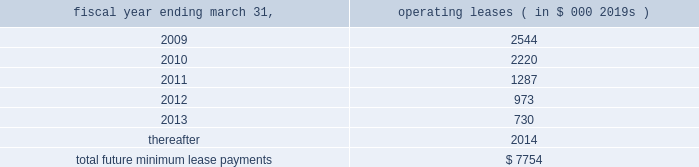Abiomed , inc .
And subsidiaries notes to consolidated financial statements 2014 ( continued ) note 15 .
Commitments and contingencies ( continued ) the company applies the disclosure provisions of fin no .
45 , guarantor 2019s accounting and disclosure requirements for guarantees , including guarantees of indebtedness of others , and interpretation of fasb statements no .
5 , 57 and 107 and rescission of fasb interpretation no .
34 ( fin no .
45 ) to its agreements that contain guarantee or indemnification clauses .
These disclosure provisions expand those required by sfas no .
5 , accounting for contingencies , by requiring that guarantors disclose certain types of guarantees , even if the likelihood of requiring the guarantor 2019s performance is remote .
In addition to product warranties , the following is a description of arrangements in which the company is a guarantor .
Indemnifications 2014in many sales transactions , the company indemnifies customers against possible claims of patent infringement caused by the company 2019s products .
The indemnifications contained within sales contracts usually do not include limits on the claims .
The company has never incurred any material costs to defend lawsuits or settle patent infringement claims related to sales transactions .
Under the provisions of fin no .
45 , intellectual property indemnifications require disclosure only .
The company enters into agreements with other companies in the ordinary course of business , typically with underwriters , contractors , clinical sites and customers that include indemnification provisions .
Under these provisions the company generally indemnifies and holds harmless the indemnified party for losses suffered or incurred by the indemnified party as a result of its activities .
These indemnification provisions generally survive termination of the underlying agreement .
The maximum potential amount of future payments the company could be required to make under these indemnification provisions is unlimited .
Abiomed has never incurred any material costs to defend lawsuits or settle claims related to these indemnification agreements .
As a result , the estimated fair value of these agreements is minimal .
Accordingly , the company has no liabilities recorded for these agreements as of march 31 , 2008 .
Clinical study agreements 2014in the company 2019s clinical study agreements , abiomed has agreed to indemnify the participating institutions against losses incurred by them for claims related to any personal injury of subjects taking part in the study to the extent they relate to uses of the company 2019s devices in accordance with the clinical study agreement , the protocol for the device and abiomed 2019s instructions .
The indemnification provisions contained within the company 2019s clinical study agreements do not generally include limits on the claims .
The company has never incurred any material costs related to the indemnification provisions contained in its clinical study agreements .
Facilities leases 2014as of march 31 , 2008 , the company had entered into leases for its facilities , including its primary operating facility in danvers , massachusetts with terms through fiscal 2010 .
The danvers lease may be extended , at the company 2019s option , for two successive additional periods of five years each with monthly rent charges to be determined based on then current fair rental values .
The company 2019s lease for its aachen location expires in december 2012 .
Total rent expense under these leases , included in the accompanying consolidated statements of operations approximated $ 2.2 million , $ 1.6 million , and $ 1.3 million for the fiscal years ended march 31 , 2008 , 2007 and 2006 , respectively .
Future minimum lease payments under all significant non-cancelable operating leases as of march 31 , 2008 are approximately as follows : fiscal year ending march 31 , operating leases ( in $ 000 2019s ) .
Litigation 2014from time-to-time , the company is involved in legal and administrative proceedings and claims of various types .
While any litigation contains an element of uncertainty , management presently believes that the outcome of each such other proceedings or claims which are pending or known to be threatened , or all of them combined , is not expected to have a material adverse effect on the company 2019s financial position , cash flow and results. .
The total rent for leases in the fiscal years ended march 31 , 2008 , 2007 and 2006 is what percent of the entire future minimum lease payments? 
Computations: (((2.2 + 1.6) + 1.3) / (7754 / 1000))
Answer: 0.65773. 